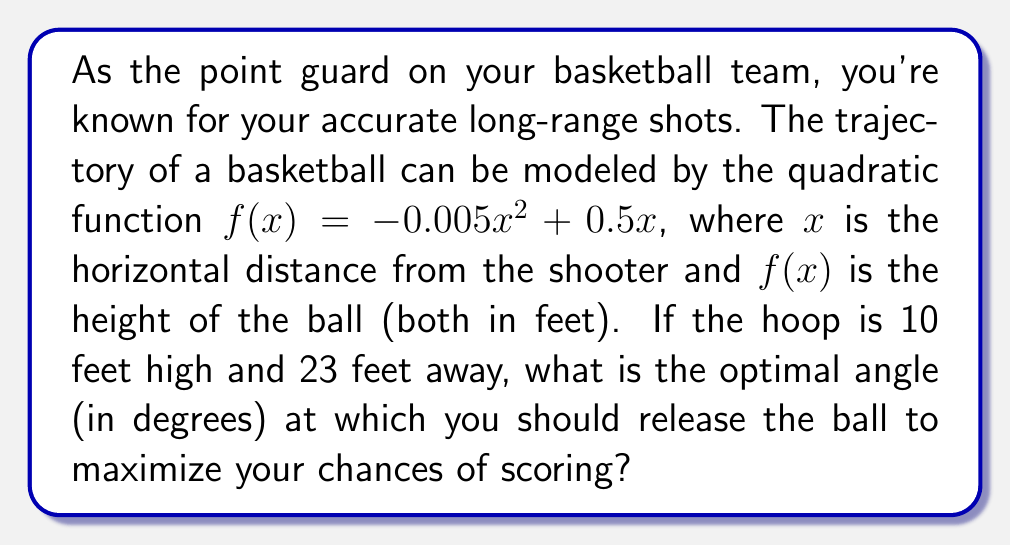Help me with this question. Let's approach this step-by-step:

1) First, we need to find the point where the ball reaches the hoop. We know that:
   $x = 23$ (horizontal distance to the hoop)
   $f(23) = 10$ (height of the hoop)

2) Let's verify if our function passes through this point:
   $f(23) = -0.005(23)^2 + 0.5(23) = -2.645 + 11.5 = 8.855$

3) The ball doesn't quite reach 10 feet at $x=23$, but it's close. This is realistic as the ball typically enters the hoop on a downward trajectory.

4) To find the angle of release, we need to calculate the derivative of $f(x)$ at $x=0$ (the release point):
   $f'(x) = -0.01x + 0.5$
   $f'(0) = 0.5$

5) The derivative at $x=0$ gives us the slope of the tangent line at the release point, which is the initial trajectory of the ball.

6) We can convert this slope to an angle using the arctangent function:
   $\theta = \arctan(0.5)$

7) Convert from radians to degrees:
   $\theta = \arctan(0.5) * \frac{180}{\pi}$

8) Calculate the result:
   $\theta \approx 26.57°$

This angle maximizes the chances of scoring by providing the optimal balance between height and distance for the given trajectory.
Answer: $26.57°$ 